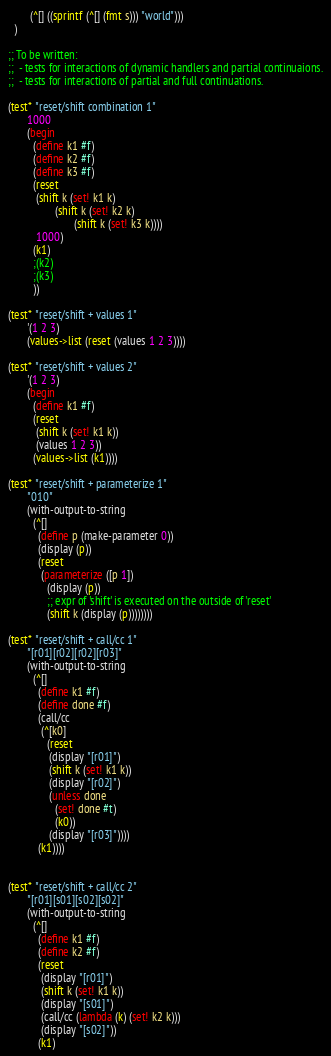<code> <loc_0><loc_0><loc_500><loc_500><_Scheme_>        (^[] ((sprintf (^[] (fmt s))) "world")))
  )

;; To be written:
;;  - tests for interactions of dynamic handlers and partial continuaions.
;;  - tests for interactions of partial and full continuations.

(test* "reset/shift combination 1"
       1000
       (begin
         (define k1 #f)
         (define k2 #f)
         (define k3 #f)
         (reset
          (shift k (set! k1 k)
                 (shift k (set! k2 k)
                        (shift k (set! k3 k))))
          1000)
         (k1)
         ;(k2)
         ;(k3)
         ))

(test* "reset/shift + values 1"
       '(1 2 3)
       (values->list (reset (values 1 2 3))))

(test* "reset/shift + values 2"
       '(1 2 3)
       (begin
         (define k1 #f)
         (reset
          (shift k (set! k1 k))
          (values 1 2 3))
         (values->list (k1))))

(test* "reset/shift + parameterize 1"
       "010"
       (with-output-to-string
         (^[]
           (define p (make-parameter 0))
           (display (p))
           (reset
            (parameterize ([p 1])
              (display (p))
              ;; expr of 'shift' is executed on the outside of 'reset'
              (shift k (display (p))))))))

(test* "reset/shift + call/cc 1"
       "[r01][r02][r02][r03]"
       (with-output-to-string
         (^[]
           (define k1 #f)
           (define done #f)
           (call/cc
            (^[k0]
              (reset
               (display "[r01]")
               (shift k (set! k1 k))
               (display "[r02]")
               (unless done
                 (set! done #t)
                 (k0))
               (display "[r03]"))))
           (k1))))


(test* "reset/shift + call/cc 2"
       "[r01][s01][s02][s02]"
       (with-output-to-string
         (^[]
           (define k1 #f)
           (define k2 #f)
           (reset
            (display "[r01]")
            (shift k (set! k1 k))
            (display "[s01]")
            (call/cc (lambda (k) (set! k2 k)))
            (display "[s02]"))
           (k1)</code> 